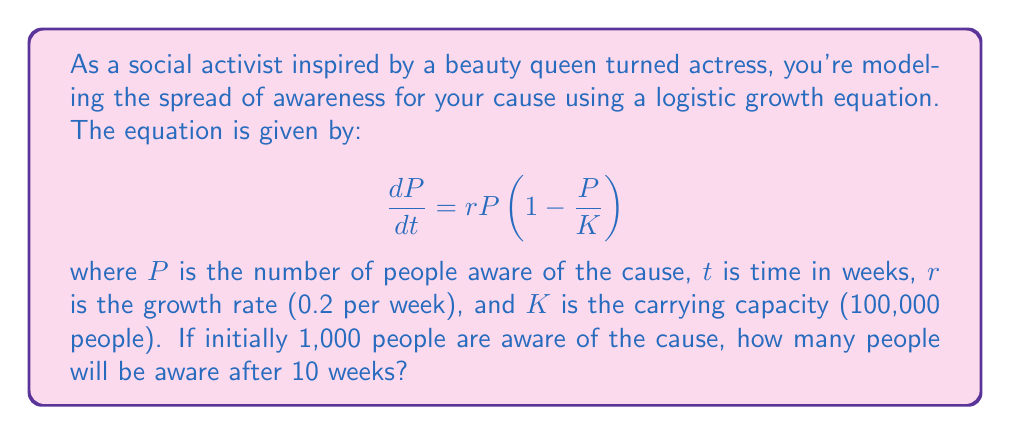Could you help me with this problem? To solve this problem, we need to use the solution to the logistic growth equation:

$$P(t) = \frac{K}{1 + (\frac{K}{P_0} - 1)e^{-rt}}$$

Where:
$K = 100,000$ (carrying capacity)
$P_0 = 1,000$ (initial population)
$r = 0.2$ (growth rate per week)
$t = 10$ (time in weeks)

Let's substitute these values into the equation:

$$P(10) = \frac{100,000}{1 + (\frac{100,000}{1,000} - 1)e^{-0.2 \cdot 10}}$$

$$= \frac{100,000}{1 + (99)e^{-2}}$$

$$= \frac{100,000}{1 + 99 \cdot 0.1353}$$

$$= \frac{100,000}{1 + 13.3947}$$

$$= \frac{100,000}{14.3947}$$

$$= 6,947.23$$

Rounding to the nearest whole number (as we can't have fractional people), we get 6,947 people aware of the cause after 10 weeks.
Answer: 6,947 people 